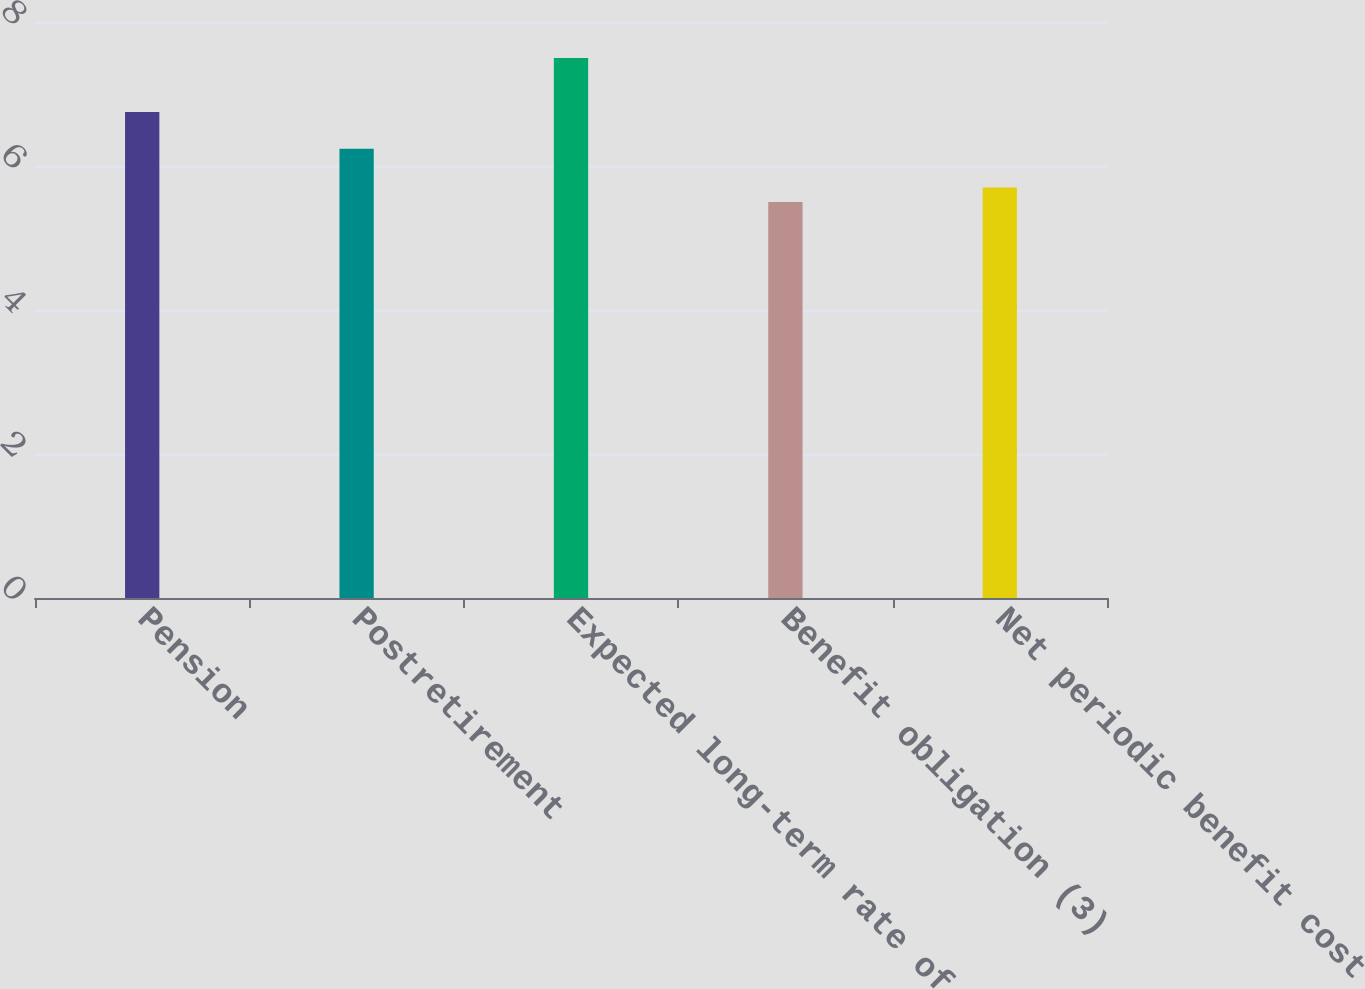Convert chart. <chart><loc_0><loc_0><loc_500><loc_500><bar_chart><fcel>Pension<fcel>Postretirement<fcel>Expected long-term rate of<fcel>Benefit obligation (3)<fcel>Net periodic benefit cost<nl><fcel>6.75<fcel>6.24<fcel>7.5<fcel>5.5<fcel>5.7<nl></chart> 